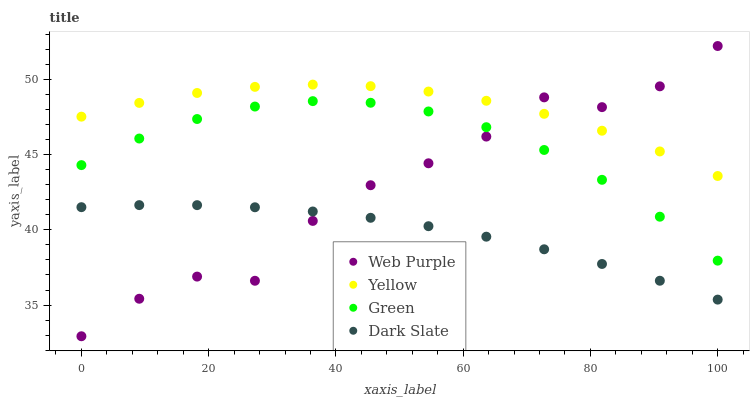Does Dark Slate have the minimum area under the curve?
Answer yes or no. Yes. Does Yellow have the maximum area under the curve?
Answer yes or no. Yes. Does Web Purple have the minimum area under the curve?
Answer yes or no. No. Does Web Purple have the maximum area under the curve?
Answer yes or no. No. Is Dark Slate the smoothest?
Answer yes or no. Yes. Is Web Purple the roughest?
Answer yes or no. Yes. Is Green the smoothest?
Answer yes or no. No. Is Green the roughest?
Answer yes or no. No. Does Web Purple have the lowest value?
Answer yes or no. Yes. Does Green have the lowest value?
Answer yes or no. No. Does Web Purple have the highest value?
Answer yes or no. Yes. Does Green have the highest value?
Answer yes or no. No. Is Dark Slate less than Green?
Answer yes or no. Yes. Is Green greater than Dark Slate?
Answer yes or no. Yes. Does Dark Slate intersect Web Purple?
Answer yes or no. Yes. Is Dark Slate less than Web Purple?
Answer yes or no. No. Is Dark Slate greater than Web Purple?
Answer yes or no. No. Does Dark Slate intersect Green?
Answer yes or no. No. 